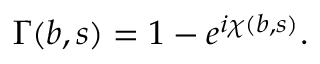Convert formula to latex. <formula><loc_0><loc_0><loc_500><loc_500>\Gamma ( b , s ) = 1 - e ^ { i \chi ( b , s ) } .</formula> 